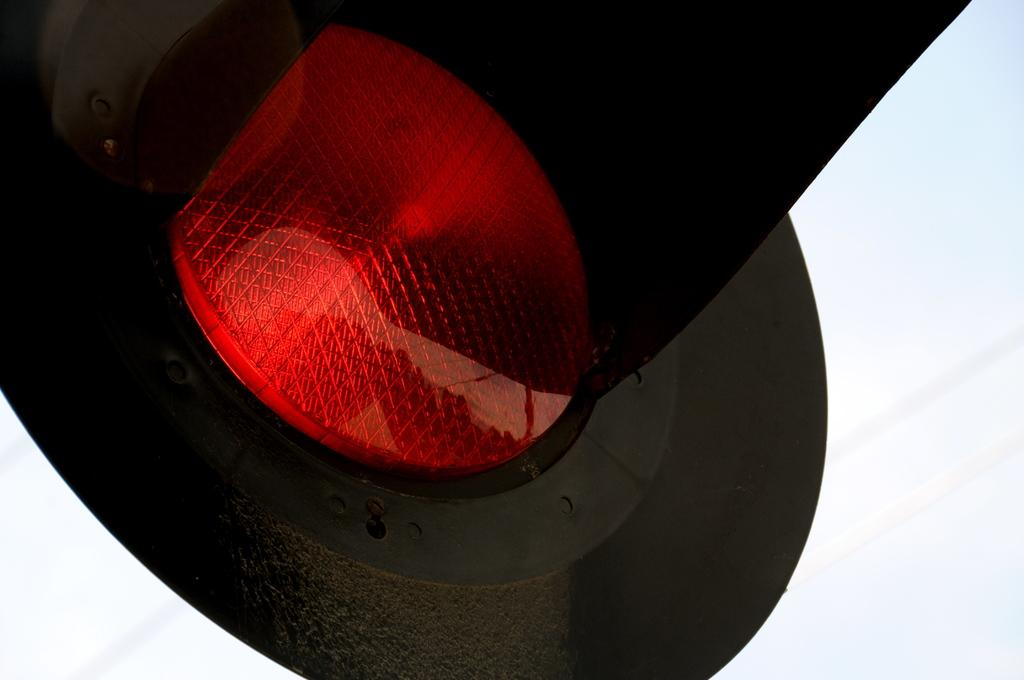What color is the light in the image? The light in the image is red. What color is the background of the image? The background of the image is white. What type of sound can be heard coming from the red light in the image? There is no sound associated with the red light in the image. How many dimes are visible on the white background in the image? There are no dimes present in the image. 